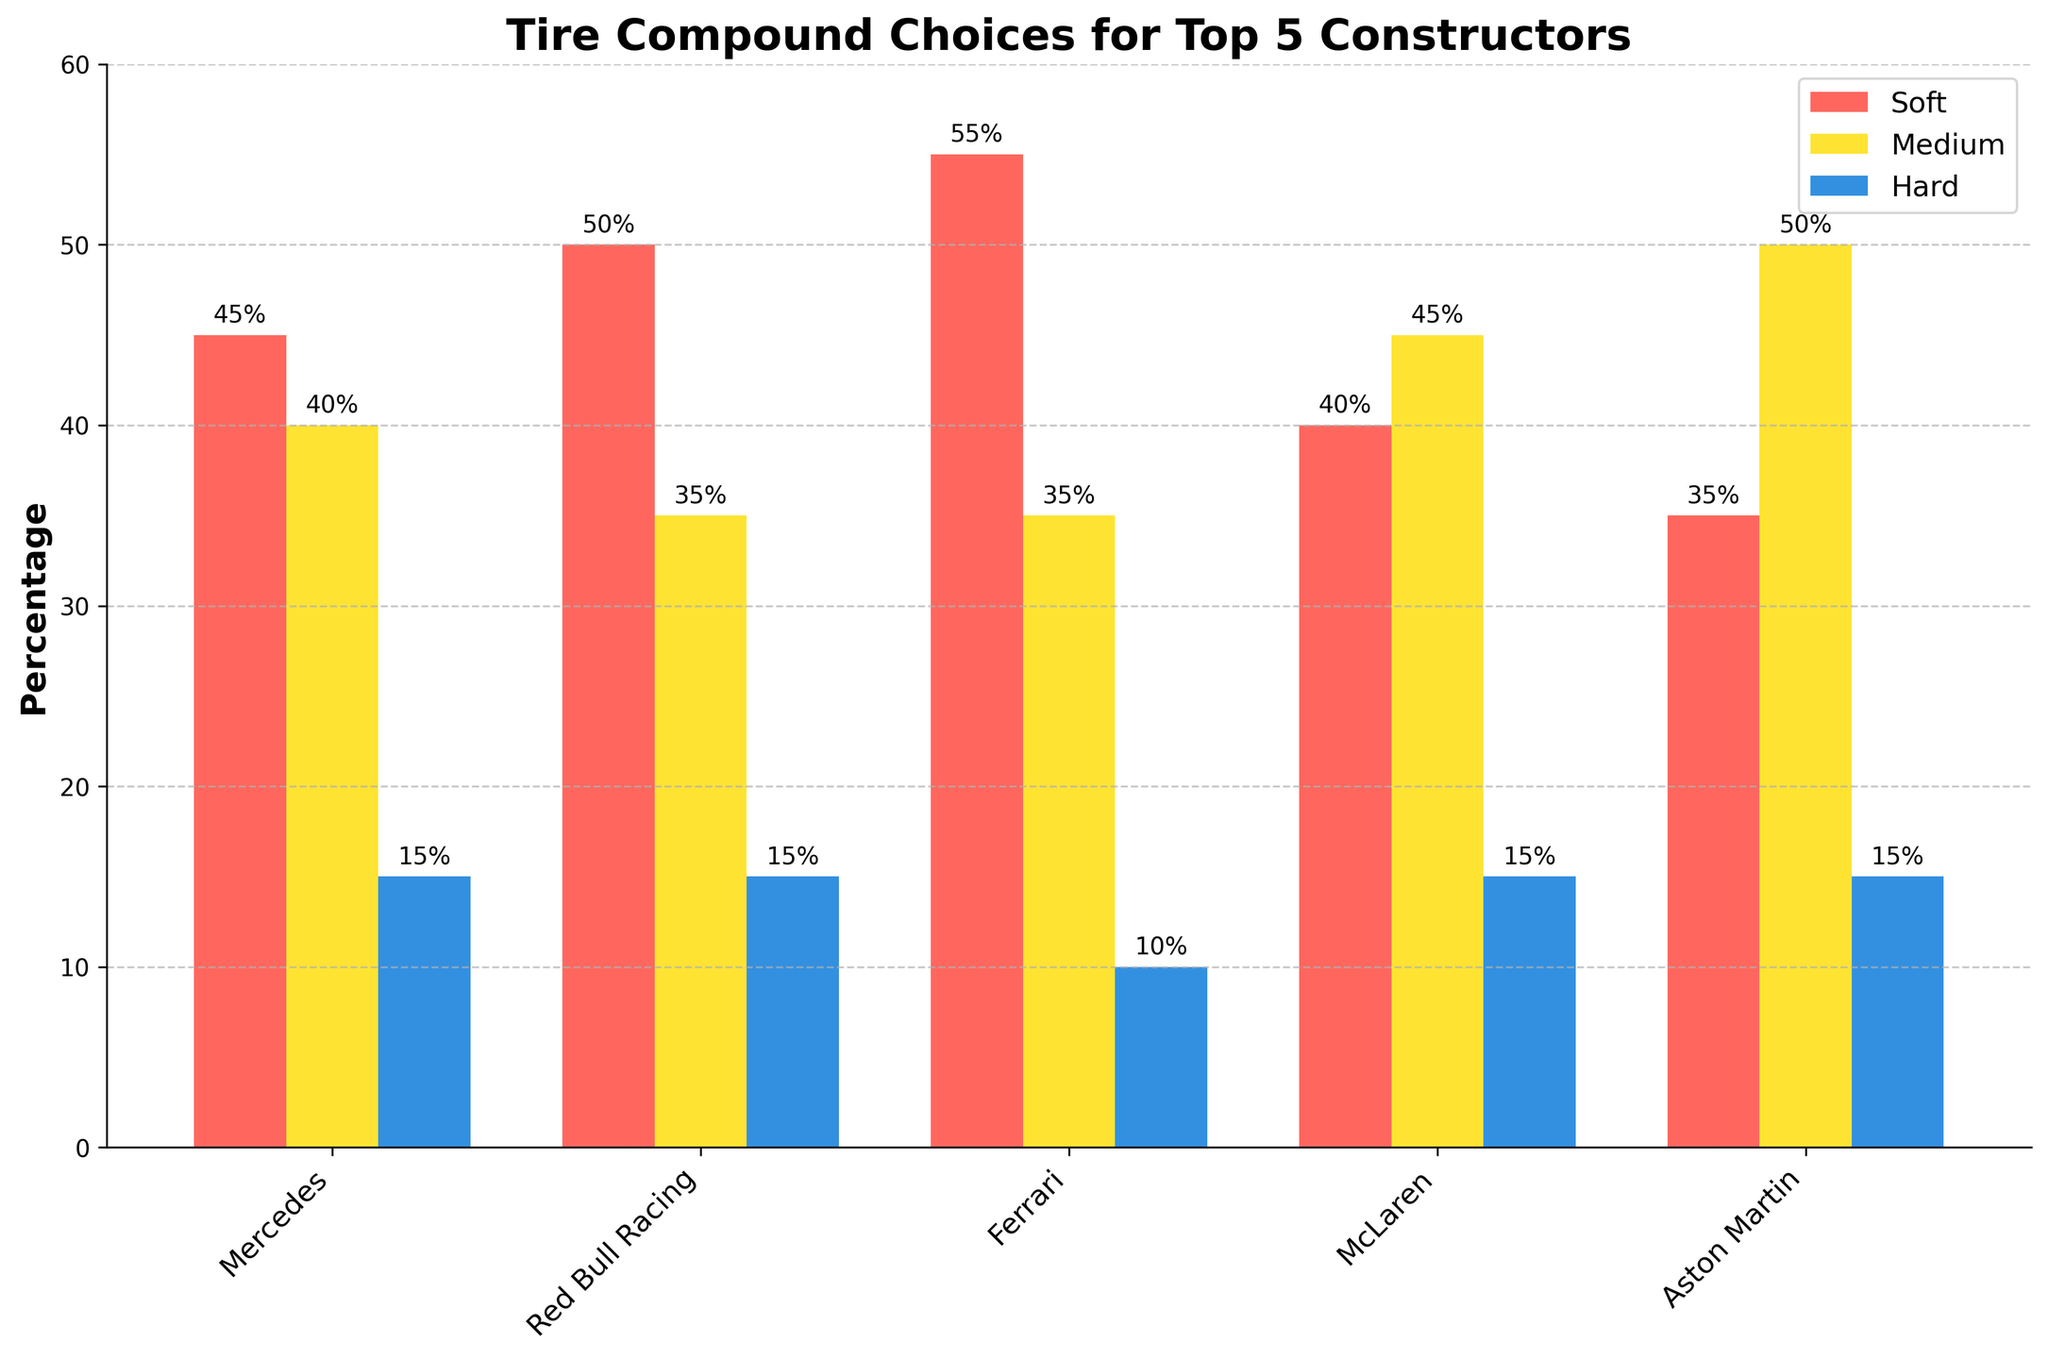What is the most chosen tire compound by Ferrari? The bar section representing tire compound choices for Ferrari shows that the Soft compound is the highest with 55%.
Answer: Soft Which constructor has the highest percentage of Medium tire compound usage? Looking at the height of the bars labeled "Medium" for each constructor, Aston Martin has the highest usage at 50%.
Answer: Aston Martin How does McLaren's selection of tire compounds compare to Mercedes'? McLaren has 40% Soft, 45% Medium, and 15% Hard. Mercedes has 45% Soft, 40% Medium, and 15% Hard. Comparing both, McLaren uses less Soft, more Medium, and the same percentage of Hard compounds.
Answer: McLaren uses less Soft and more Medium Which constructor has the smallest difference between their Soft and Medium tire compound choices? The differences are as follows: Mercedes (45-40=5), Red Bull Racing (50-35=15), Ferrari (55-35=20), McLaren (40-45=5), Aston Martin (35-50=15). Both Mercedes and McLaren have the smallest difference of 5 percentage points.
Answer: Mercedes and McLaren What is the average percentage of Hard tire usage among the top 5 constructors? Average = (15% + 15% + 10% + 15% + 15%) / 5 = 14%
Answer: 14% Which constructors have chosen the Hard tire compound exactly 15% of the time? The bar sections for Hard tire compound show that Mercedes, Red Bull Racing, McLaren, and Aston Martin each have 15%.
Answer: Mercedes, Red Bull Racing, McLaren, Aston Martin What is the total percentage for Medium tire compound choices when summed for all constructors? The total is 40% (Mercedes) + 35% (Red Bull Racing) + 35% (Ferrari) + 45% (McLaren) + 50% (Aston Martin) = 205%
Answer: 205% How does Red Bull Racing's Soft tire percentage compare to Ferrari's? Red Bull Racing has 50% Soft tire usage while Ferrari has 55% Soft tire usage, so Ferrari uses 5 percentage points more.
Answer: Ferrari uses 5% more What percentage of the tire compound choices for McLaren are not Soft? McLaren's non-Soft tire compounds include Medium (45%) and Hard (15%), totaling 45% + 15% = 60%.
Answer: 60% What is the percentage range (difference between highest and lowest) of Soft tire usage among all constructors? The range is found by determining the highest and lowest values: Ferrari (55%) - Aston Martin (35%) = 20%.
Answer: 20% 